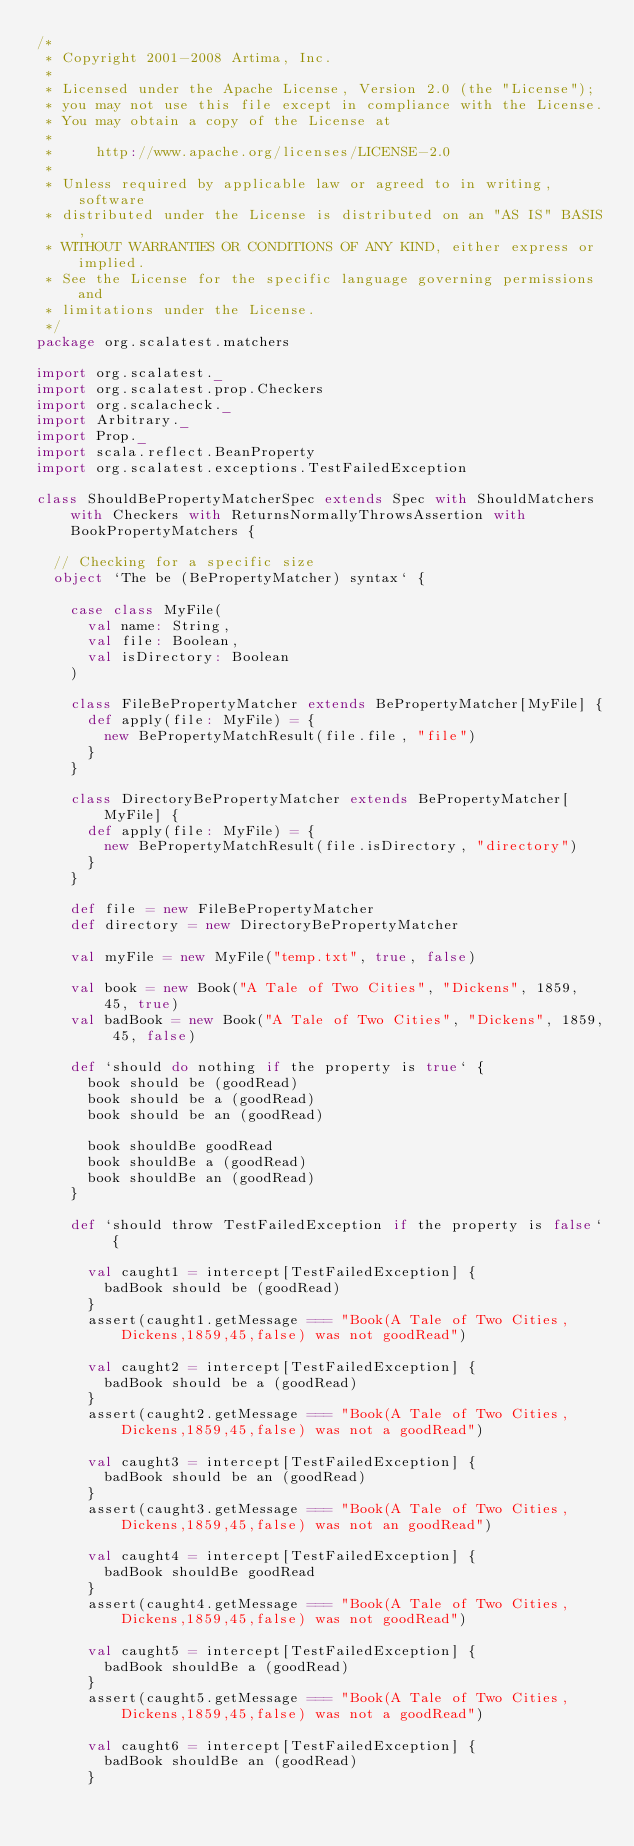<code> <loc_0><loc_0><loc_500><loc_500><_Scala_>/*
 * Copyright 2001-2008 Artima, Inc.
 *
 * Licensed under the Apache License, Version 2.0 (the "License");
 * you may not use this file except in compliance with the License.
 * You may obtain a copy of the License at
 *
 *     http://www.apache.org/licenses/LICENSE-2.0
 *
 * Unless required by applicable law or agreed to in writing, software
 * distributed under the License is distributed on an "AS IS" BASIS,
 * WITHOUT WARRANTIES OR CONDITIONS OF ANY KIND, either express or implied.
 * See the License for the specific language governing permissions and
 * limitations under the License.
 */
package org.scalatest.matchers

import org.scalatest._
import org.scalatest.prop.Checkers
import org.scalacheck._
import Arbitrary._
import Prop._
import scala.reflect.BeanProperty
import org.scalatest.exceptions.TestFailedException

class ShouldBePropertyMatcherSpec extends Spec with ShouldMatchers with Checkers with ReturnsNormallyThrowsAssertion with BookPropertyMatchers {

  // Checking for a specific size
  object `The be (BePropertyMatcher) syntax` {

    case class MyFile(
      val name: String,
      val file: Boolean,
      val isDirectory: Boolean
    )

    class FileBePropertyMatcher extends BePropertyMatcher[MyFile] {
      def apply(file: MyFile) = {
        new BePropertyMatchResult(file.file, "file")
      }
    }

    class DirectoryBePropertyMatcher extends BePropertyMatcher[MyFile] {
      def apply(file: MyFile) = {
        new BePropertyMatchResult(file.isDirectory, "directory")
      }
    }

    def file = new FileBePropertyMatcher
    def directory = new DirectoryBePropertyMatcher

    val myFile = new MyFile("temp.txt", true, false)

    val book = new Book("A Tale of Two Cities", "Dickens", 1859, 45, true)
    val badBook = new Book("A Tale of Two Cities", "Dickens", 1859, 45, false)

    def `should do nothing if the property is true` {
      book should be (goodRead)
      book should be a (goodRead)
      book should be an (goodRead)
      
      book shouldBe goodRead
      book shouldBe a (goodRead)
      book shouldBe an (goodRead)
    }

    def `should throw TestFailedException if the property is false` {

      val caught1 = intercept[TestFailedException] {
        badBook should be (goodRead)
      }
      assert(caught1.getMessage === "Book(A Tale of Two Cities,Dickens,1859,45,false) was not goodRead")

      val caught2 = intercept[TestFailedException] {
        badBook should be a (goodRead)
      }
      assert(caught2.getMessage === "Book(A Tale of Two Cities,Dickens,1859,45,false) was not a goodRead")

      val caught3 = intercept[TestFailedException] {
        badBook should be an (goodRead)
      }
      assert(caught3.getMessage === "Book(A Tale of Two Cities,Dickens,1859,45,false) was not an goodRead")
      
      val caught4 = intercept[TestFailedException] {
        badBook shouldBe goodRead
      }
      assert(caught4.getMessage === "Book(A Tale of Two Cities,Dickens,1859,45,false) was not goodRead")

      val caught5 = intercept[TestFailedException] {
        badBook shouldBe a (goodRead)
      }
      assert(caught5.getMessage === "Book(A Tale of Two Cities,Dickens,1859,45,false) was not a goodRead")

      val caught6 = intercept[TestFailedException] {
        badBook shouldBe an (goodRead)
      }</code> 